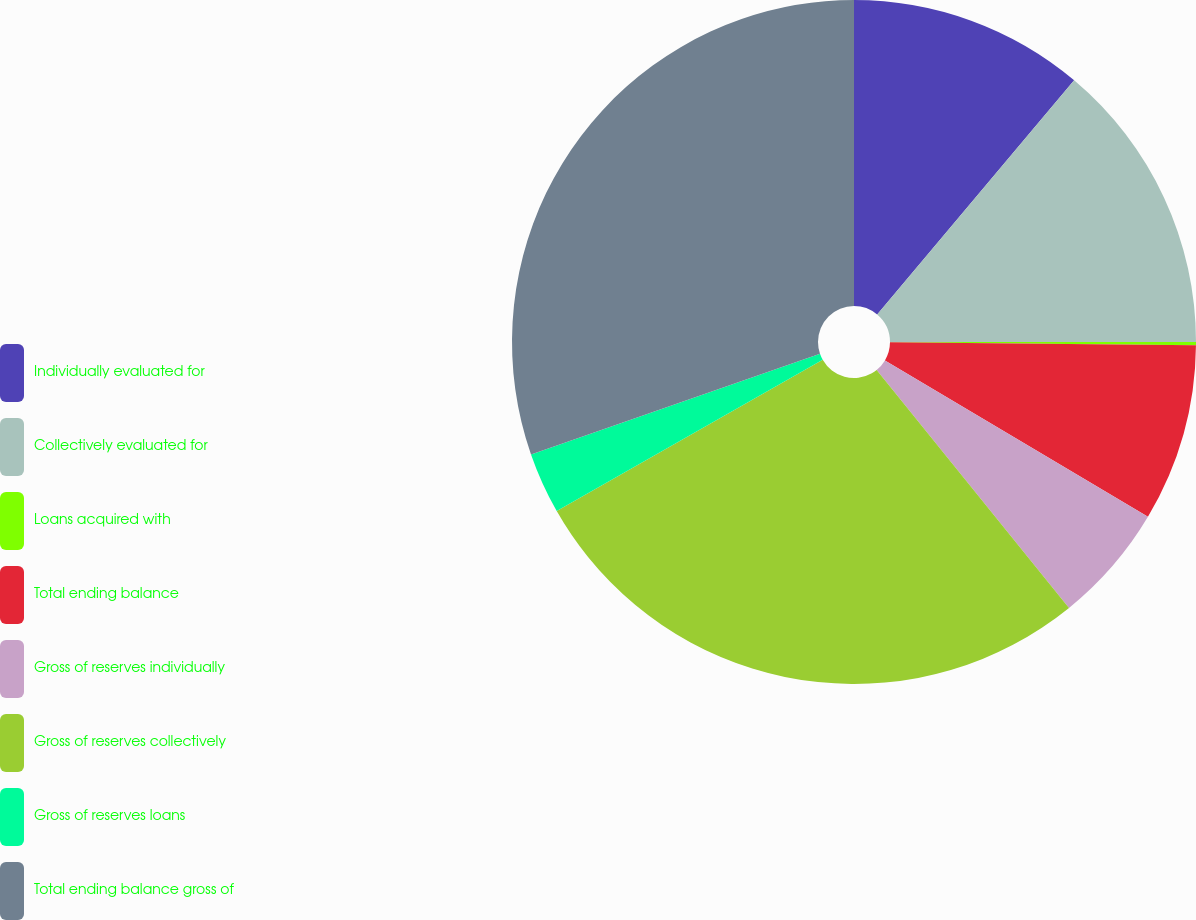<chart> <loc_0><loc_0><loc_500><loc_500><pie_chart><fcel>Individually evaluated for<fcel>Collectively evaluated for<fcel>Loans acquired with<fcel>Total ending balance<fcel>Gross of reserves individually<fcel>Gross of reserves collectively<fcel>Gross of reserves loans<fcel>Total ending balance gross of<nl><fcel>11.13%<fcel>13.87%<fcel>0.15%<fcel>8.39%<fcel>5.64%<fcel>27.59%<fcel>2.9%<fcel>30.33%<nl></chart> 